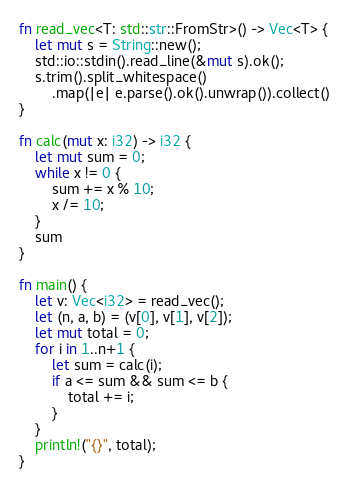<code> <loc_0><loc_0><loc_500><loc_500><_Rust_>fn read_vec<T: std::str::FromStr>() -> Vec<T> {
    let mut s = String::new();
    std::io::stdin().read_line(&mut s).ok();
    s.trim().split_whitespace()
        .map(|e| e.parse().ok().unwrap()).collect()
}

fn calc(mut x: i32) -> i32 {
    let mut sum = 0;
    while x != 0 {
        sum += x % 10;
        x /= 10;
    }
    sum
}

fn main() {
    let v: Vec<i32> = read_vec();
    let (n, a, b) = (v[0], v[1], v[2]);
    let mut total = 0;
    for i in 1..n+1 {
        let sum = calc(i);
        if a <= sum && sum <= b {
            total += i;
        }
    }
    println!("{}", total);
}
</code> 